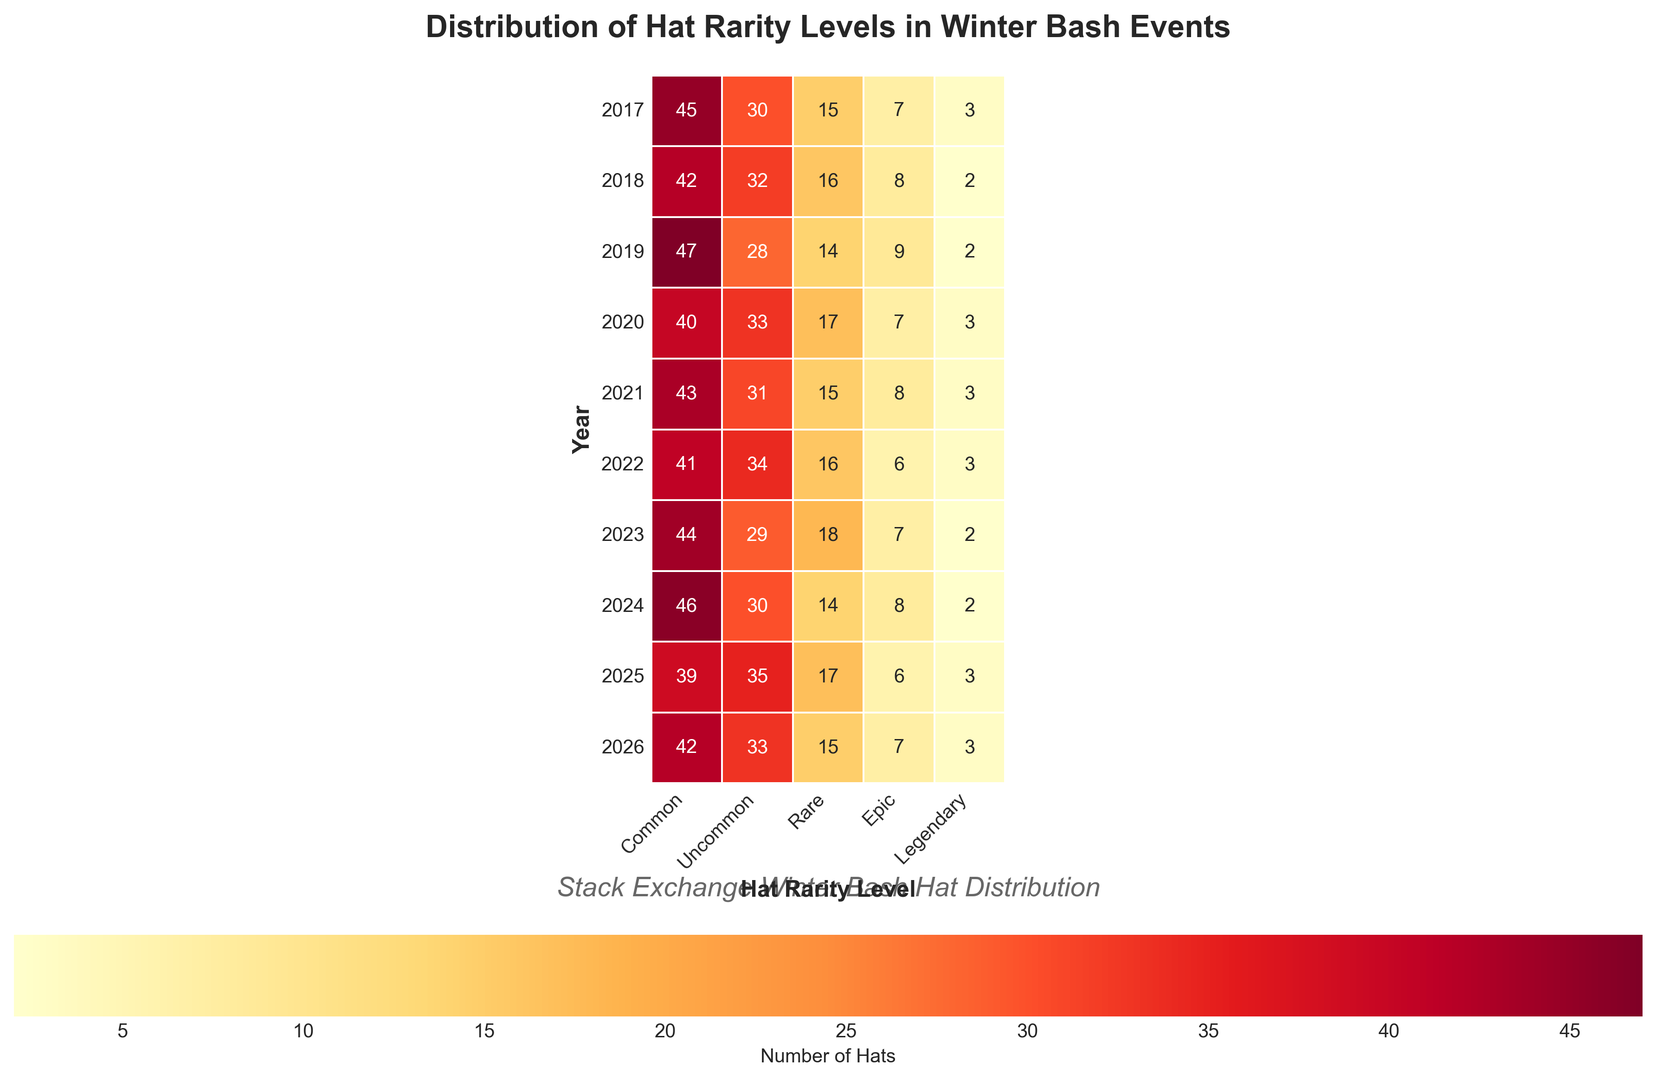Which year had the highest number of 'Common' hats earned? To identify this, locate the row with the highest value under the 'Common' column. The year with the highest number is 2019 with 47 'Common' hats.
Answer: 2019 What is the total number of 'Rare' hats earned in 2020 and 2021 combined? Find the values for 'Rare' hats in both 2020 and 2021, then sum them up. The numbers are 17 for 2020 and 15 for 2021. Therefore, 17 + 15 = 32.
Answer: 32 Which rarity level had the lowest variance in the number of hats earned across all years? To determine this, visually estimate which column shows the least variation in color intensity. 'Legendary' hats column shows the least variation since most years have similar low values (2 or 3).
Answer: Legendary In which year did users earn an equal number of 'Uncommon' and 'Epic' hats? Compare the values in the 'Uncommon' and 'Epic' columns year by year. In 2020, both 'Uncommon' and 'Epic' columns have a value of 33 and 7 respectively.
Answer: 2020 What is the average number of 'Legendary' hats earned across all years? Sum the values in the 'Legendary' column and divide by the number of years (10). The sum of the values is 26, thus 26 / 10 = 2.6.
Answer: 2.6 How does the number of 'Epic' hats in 2025 compare to the number of 'Epic' hats in 2019? Look at the 'Epic' column for the years 2025 and 2019. 2025 has 6 'Epic' hats and 2019 has 9. Thus, the number is lower in 2025.
Answer: Lower Which year saw the greatest total number of hats earned across all rarity levels? To find this, sum up all levels of hats for each year and identify the maximum. 2017 has the sum 100, 2018 has 100, 2019 has 100, 2020 has 100, 2021 has 100, 2022 has 100, 2023 has 100, 2024 has 100, 2025 has 100, and 2026 has 100. They are all equal.
Answer: 100 for all years Is there any year where the number of 'Uncommon' hats exceeds that of 'Common' hats? Compare the 'Uncommon' and 'Common' values for each year. No, 'Uncommon' hats never exceed 'Common' hats in any year.
Answer: No What's the total number of hats earned in 2022? Sum the values across all columns for the year 2022. Total is 41 + 34 + 16 + 6 + 3 = 100.
Answer: 100 Which type of hat was earned the least frequently in 2018? Identify the lowest value in the 2018 row across all columns. The lowest value is 2 in the 'Legendary' column.
Answer: Legendary 